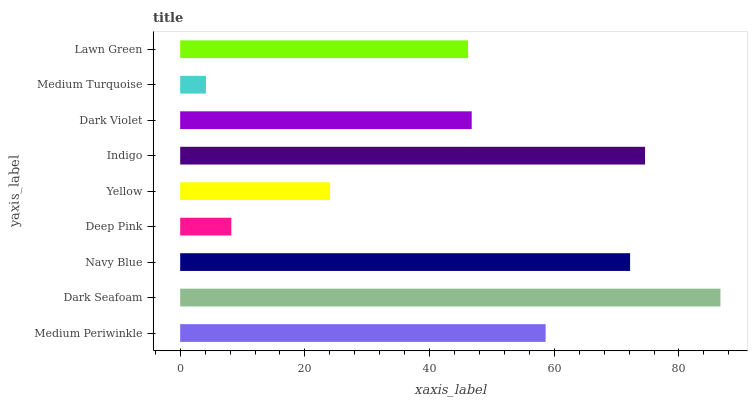Is Medium Turquoise the minimum?
Answer yes or no. Yes. Is Dark Seafoam the maximum?
Answer yes or no. Yes. Is Navy Blue the minimum?
Answer yes or no. No. Is Navy Blue the maximum?
Answer yes or no. No. Is Dark Seafoam greater than Navy Blue?
Answer yes or no. Yes. Is Navy Blue less than Dark Seafoam?
Answer yes or no. Yes. Is Navy Blue greater than Dark Seafoam?
Answer yes or no. No. Is Dark Seafoam less than Navy Blue?
Answer yes or no. No. Is Dark Violet the high median?
Answer yes or no. Yes. Is Dark Violet the low median?
Answer yes or no. Yes. Is Yellow the high median?
Answer yes or no. No. Is Navy Blue the low median?
Answer yes or no. No. 